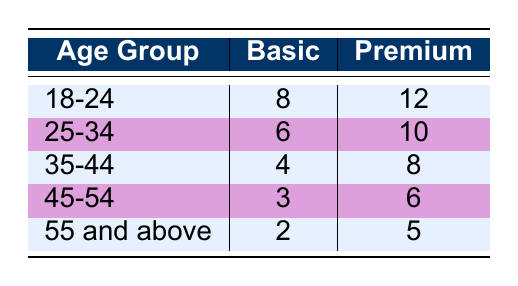1. What is the frequency of visits for the 18-24 age group with a Basic membership? From the table, the frequency of visits for the 18-24 age group under the Basic membership type is listed as 8.
Answer: 8 2. Which age group has the highest frequency of visits with a Premium membership? Referring to the table, the 18-24 age group has the highest frequency of visits with a Premium membership, which is 12.
Answer: 18-24 3. What is the average frequency of visits for the 25-34 age group across both membership types? To find the average, sum the frequency of visits for the 25-34 age group: 6 (Basic) + 10 (Premium) = 16. There are 2 membership types, so the average is 16 / 2 = 8.
Answer: 8 4. Is the frequency of visits for the 45-54 age group with a Basic membership greater than that of the 35-44 age group with a Premium membership? The frequency for the 45-54 age group with a Basic membership is 3 and for the 35-44 age group with a Premium membership is 8. Since 3 is not greater than 8, the statement is false.
Answer: No 5. What is the total frequency of visits for all age groups with a Premium membership? The total frequency of visits for Premium members is calculated as follows: 12 (18-24) + 10 (25-34) + 8 (35-44) + 6 (45-54) + 5 (55 and above) = 41.
Answer: 41 6. Which membership type has a lower overall frequency of visits when combining all age groups? The total frequency of visits for Basic members is 8 (18-24) + 6 (25-34) + 4 (35-44) + 3 (45-54) + 2 (55 and above) = 23. For Premium members, it's 12 (18-24) + 10 (25-34) + 8 (35-44) + 6 (45-54) + 5 (55 and above) = 41. Therefore, Basic has lower frequency.
Answer: Basic 7. Are there more visits for the 35-44 age group with a Premium membership compared to 25-34 age group with a Basic membership? The frequency of visits for the 35-44 age group with a Premium membership is 8, while for the 25-34 age group with a Basic membership it is 6. Since 8 is greater than 6, the statement is true.
Answer: Yes 8. If we compare the 55 and above age group's Basic membership frequency to the 45-54 age group's Premium membership frequency, which is higher? For the 55 and above age group with a Basic membership, the frequency is 2, compared to the 45-54 age group with a Premium membership, which is 6. Since 2 is less than 6, the 45-54 age group has a higher frequency.
Answer: 45-54 9. What is the difference in frequency of visits between the Basic and Premium members in the 25-34 age group? For the 25-34 age group, the frequency of visits with Basic membership is 6, and with Premium membership it is 10. The difference is calculated by 10 - 6 = 4.
Answer: 4 